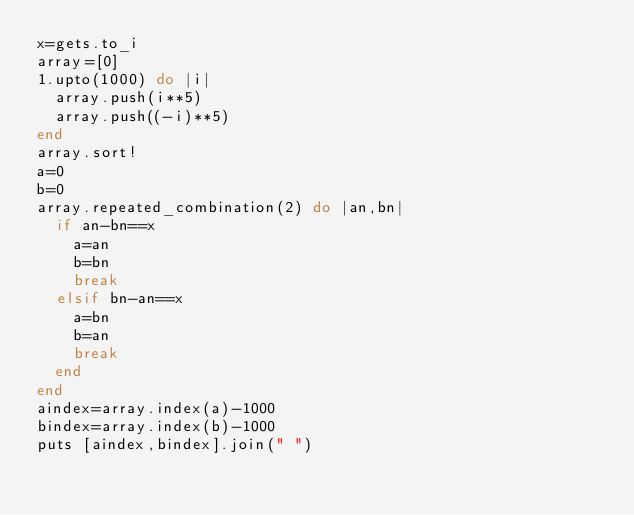Convert code to text. <code><loc_0><loc_0><loc_500><loc_500><_Ruby_>x=gets.to_i
array=[0]
1.upto(1000) do |i|
  array.push(i**5)
  array.push((-i)**5)
end
array.sort!
a=0
b=0
array.repeated_combination(2) do |an,bn|
  if an-bn==x
    a=an
    b=bn
    break
  elsif bn-an==x
    a=bn
    b=an
    break
  end
end
aindex=array.index(a)-1000
bindex=array.index(b)-1000
puts [aindex,bindex].join(" ")
</code> 